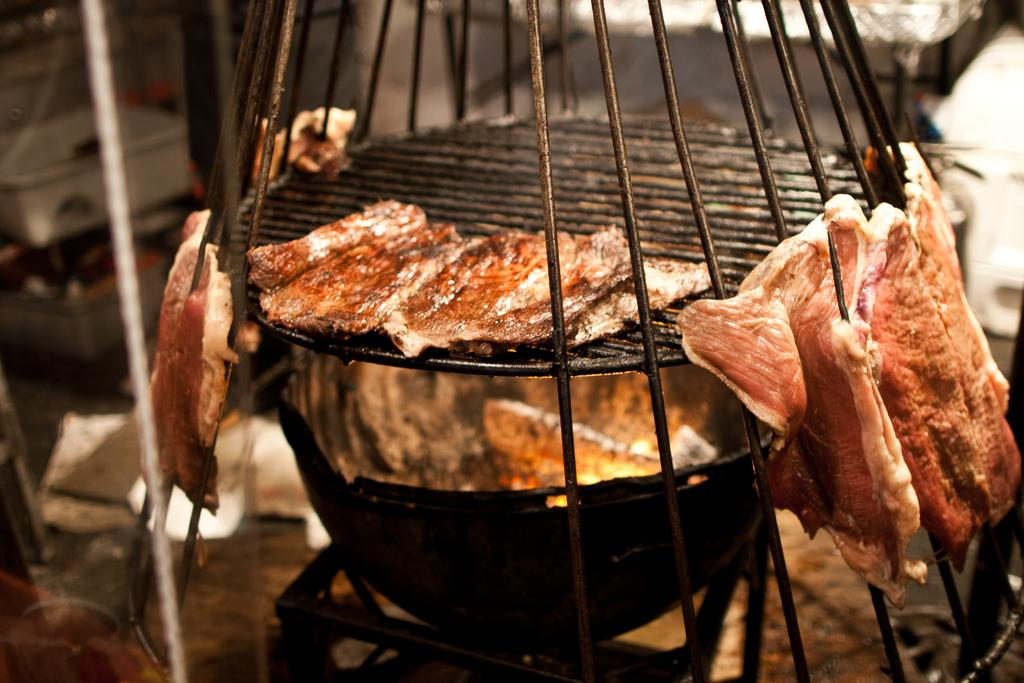What is the main object in the image? There is a grill in the image. What is being cooked on the grill? There is meat in the image. What is the source of heat for cooking the meat? There is fire in the image. How many cents are visible on the grill in the image? There are no cents visible on the grill in the image. What type of bun is being used to hold the meat in the image? There is no bun present in the image; the meat is being cooked directly on the grill. 